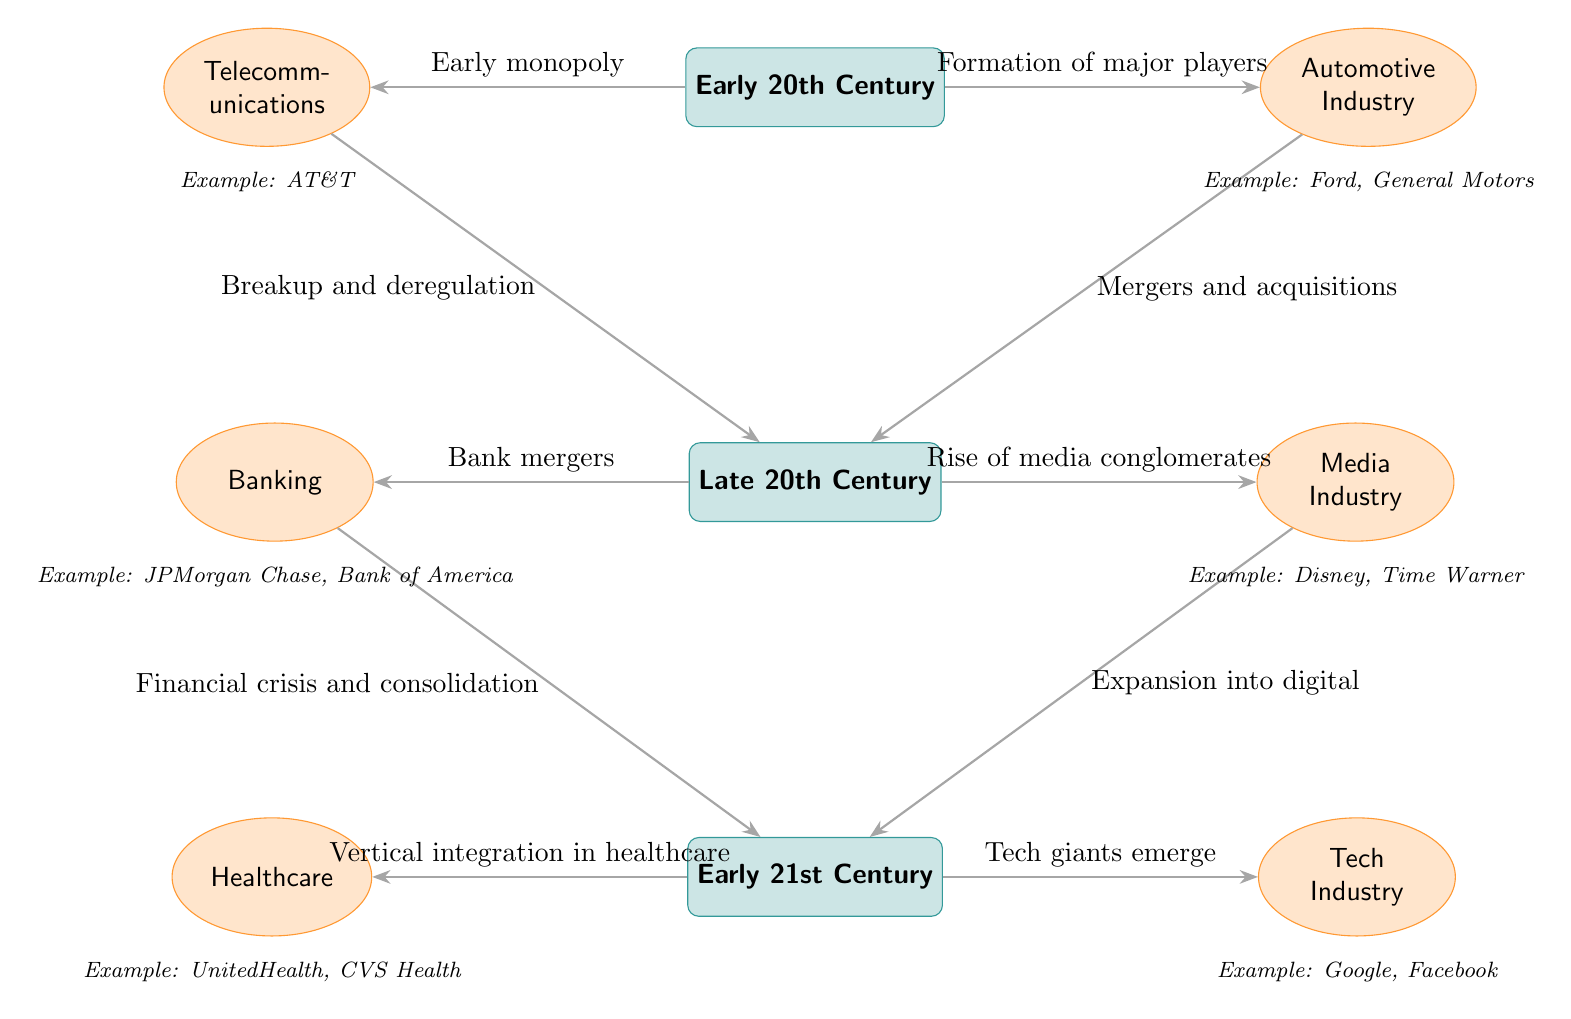What industries are represented in the early 20th century? The diagram shows the Automotive and Telecommunications industries represented for the early 20th century. These industries are depicted next to the "Early 20th Century" node.
Answer: Automotive, Telecommunications How many time periods are displayed in the diagram? The diagram displays three time periods: Early 20th Century, Late 20th Century, and Early 21st Century. This can be counted directly from the time period nodes.
Answer: 3 What key transition occurs between the Early 20th Century and Late 20th Century in the Automotive Industry? The transition from Early 20th Century to Late 20th Century shows "Mergers and acquisitions" for the Automotive Industry. This relationship is indicated by the arrow connecting the two.
Answer: Mergers and acquisitions Which industries show a relationship with consolidation in the Early 21st Century? The Tech Industry and Healthcare Industry show relationships with consolidation in the Early 21st Century, indicated by the arrows leading from the Late 20th Century to these industries.
Answer: Tech, Healthcare What major change happens in the Media Industry from Late 20th Century to Early 21st Century? The diagram indicates that the Media Industry experiences "Expansion into digital" when transitioning to the Early 21st Century. This is shown by the arrow leading from the Media Industry to the Early 21st Century.
Answer: Expansion into digital How does the diagram suggest the impact of the financial crisis on the Banking Industry? The Banking Industry transitions into the Early 21st Century with the label "Financial crisis and consolidation," indicating that the financial crisis led to further consolidation in this sector. This is illustrated by the arrow showing this relationship.
Answer: Financial crisis and consolidation What are two examples provided for the Telecommunications industry? The example given for the Telecommunications industry in the diagram is AT&T, which is positioned below the industry node. This indicates that it is a notable case study relevant to the industry during the period depicted.
Answer: AT&T Which time period is directly connected to the rise of media conglomerates? The Late 20th Century is directly connected to the rise of media conglomerates. This connection is highlighted on the arrow that leads from the Late 20th Century to the Media Industry node.
Answer: Late 20th Century 